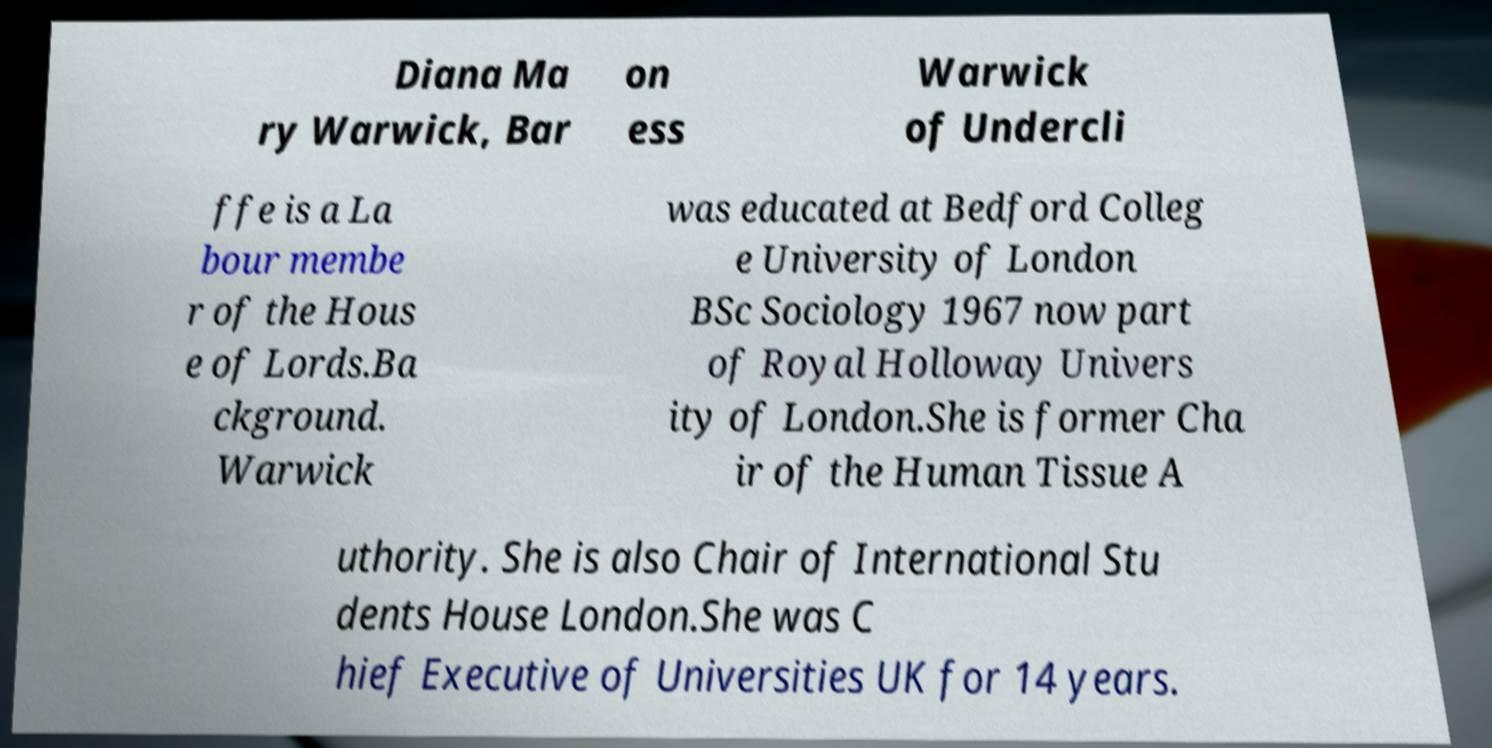For documentation purposes, I need the text within this image transcribed. Could you provide that? Diana Ma ry Warwick, Bar on ess Warwick of Undercli ffe is a La bour membe r of the Hous e of Lords.Ba ckground. Warwick was educated at Bedford Colleg e University of London BSc Sociology 1967 now part of Royal Holloway Univers ity of London.She is former Cha ir of the Human Tissue A uthority. She is also Chair of International Stu dents House London.She was C hief Executive of Universities UK for 14 years. 